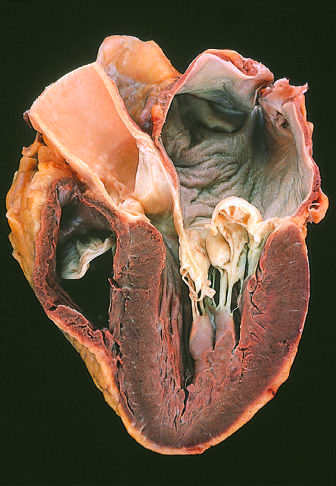s the atrium dilated, reflecting long-standing valvular insufficiency and volume overload?
Answer the question using a single word or phrase. Yes 